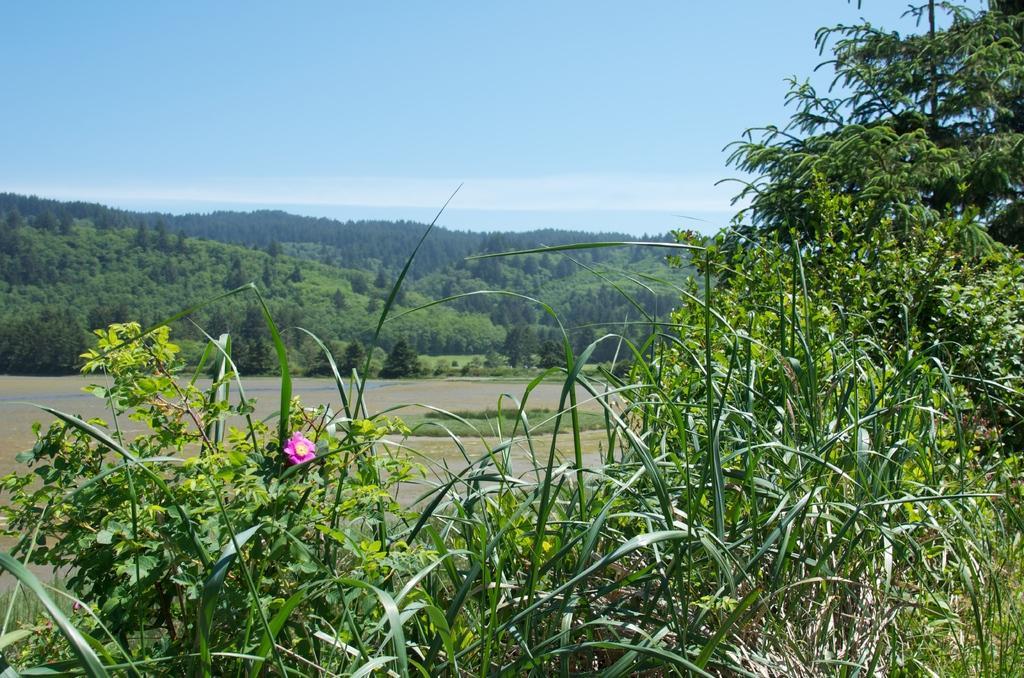Please provide a concise description of this image. On the bottom we can see pink color flower on the plant. In the back we can see river. In the background we can see mountains and many trees. On the top we can see sky and clouds. 